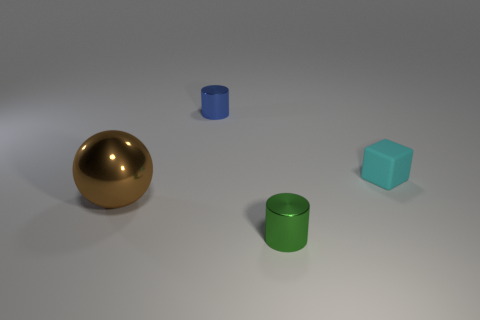What might be the relative sizes of the objects in this image? The golden sphere seems to be the largest object. The green cylinder is the second largest, followed by the cyan cube. The tiny shiny blue cylinder appears to be the smallest object. The perspective suggests that the objects are placed at varying distances from the viewpoint, which also affects their apparent size. 